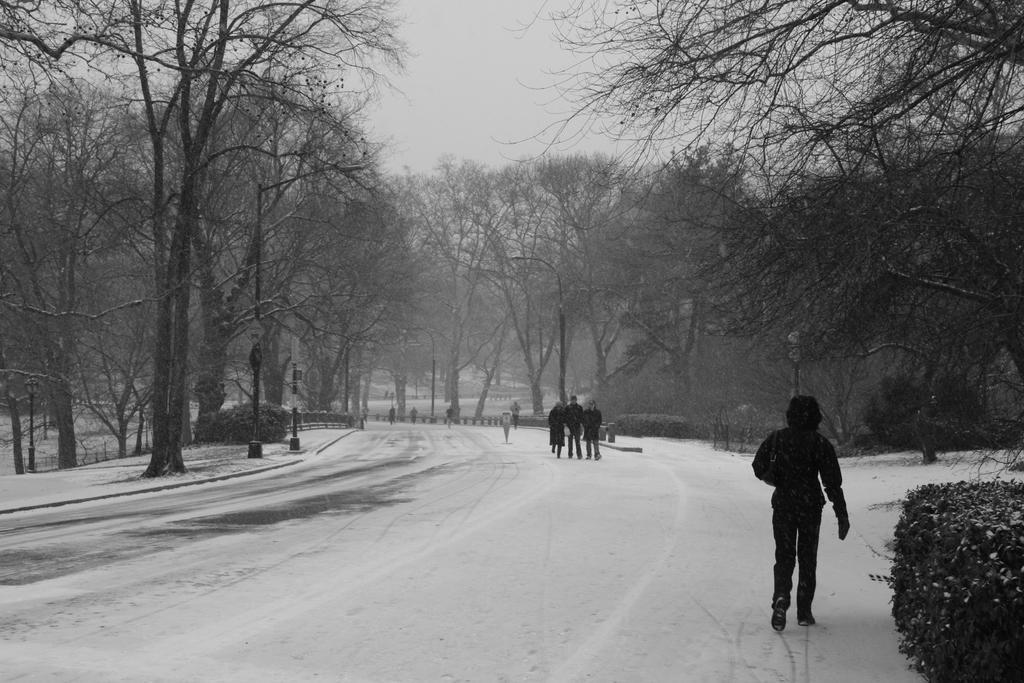Please provide a concise description of this image. It is a black and white image, there is a land covered with a lot of snow and few people were walking on that land and around that place there are many trees. 